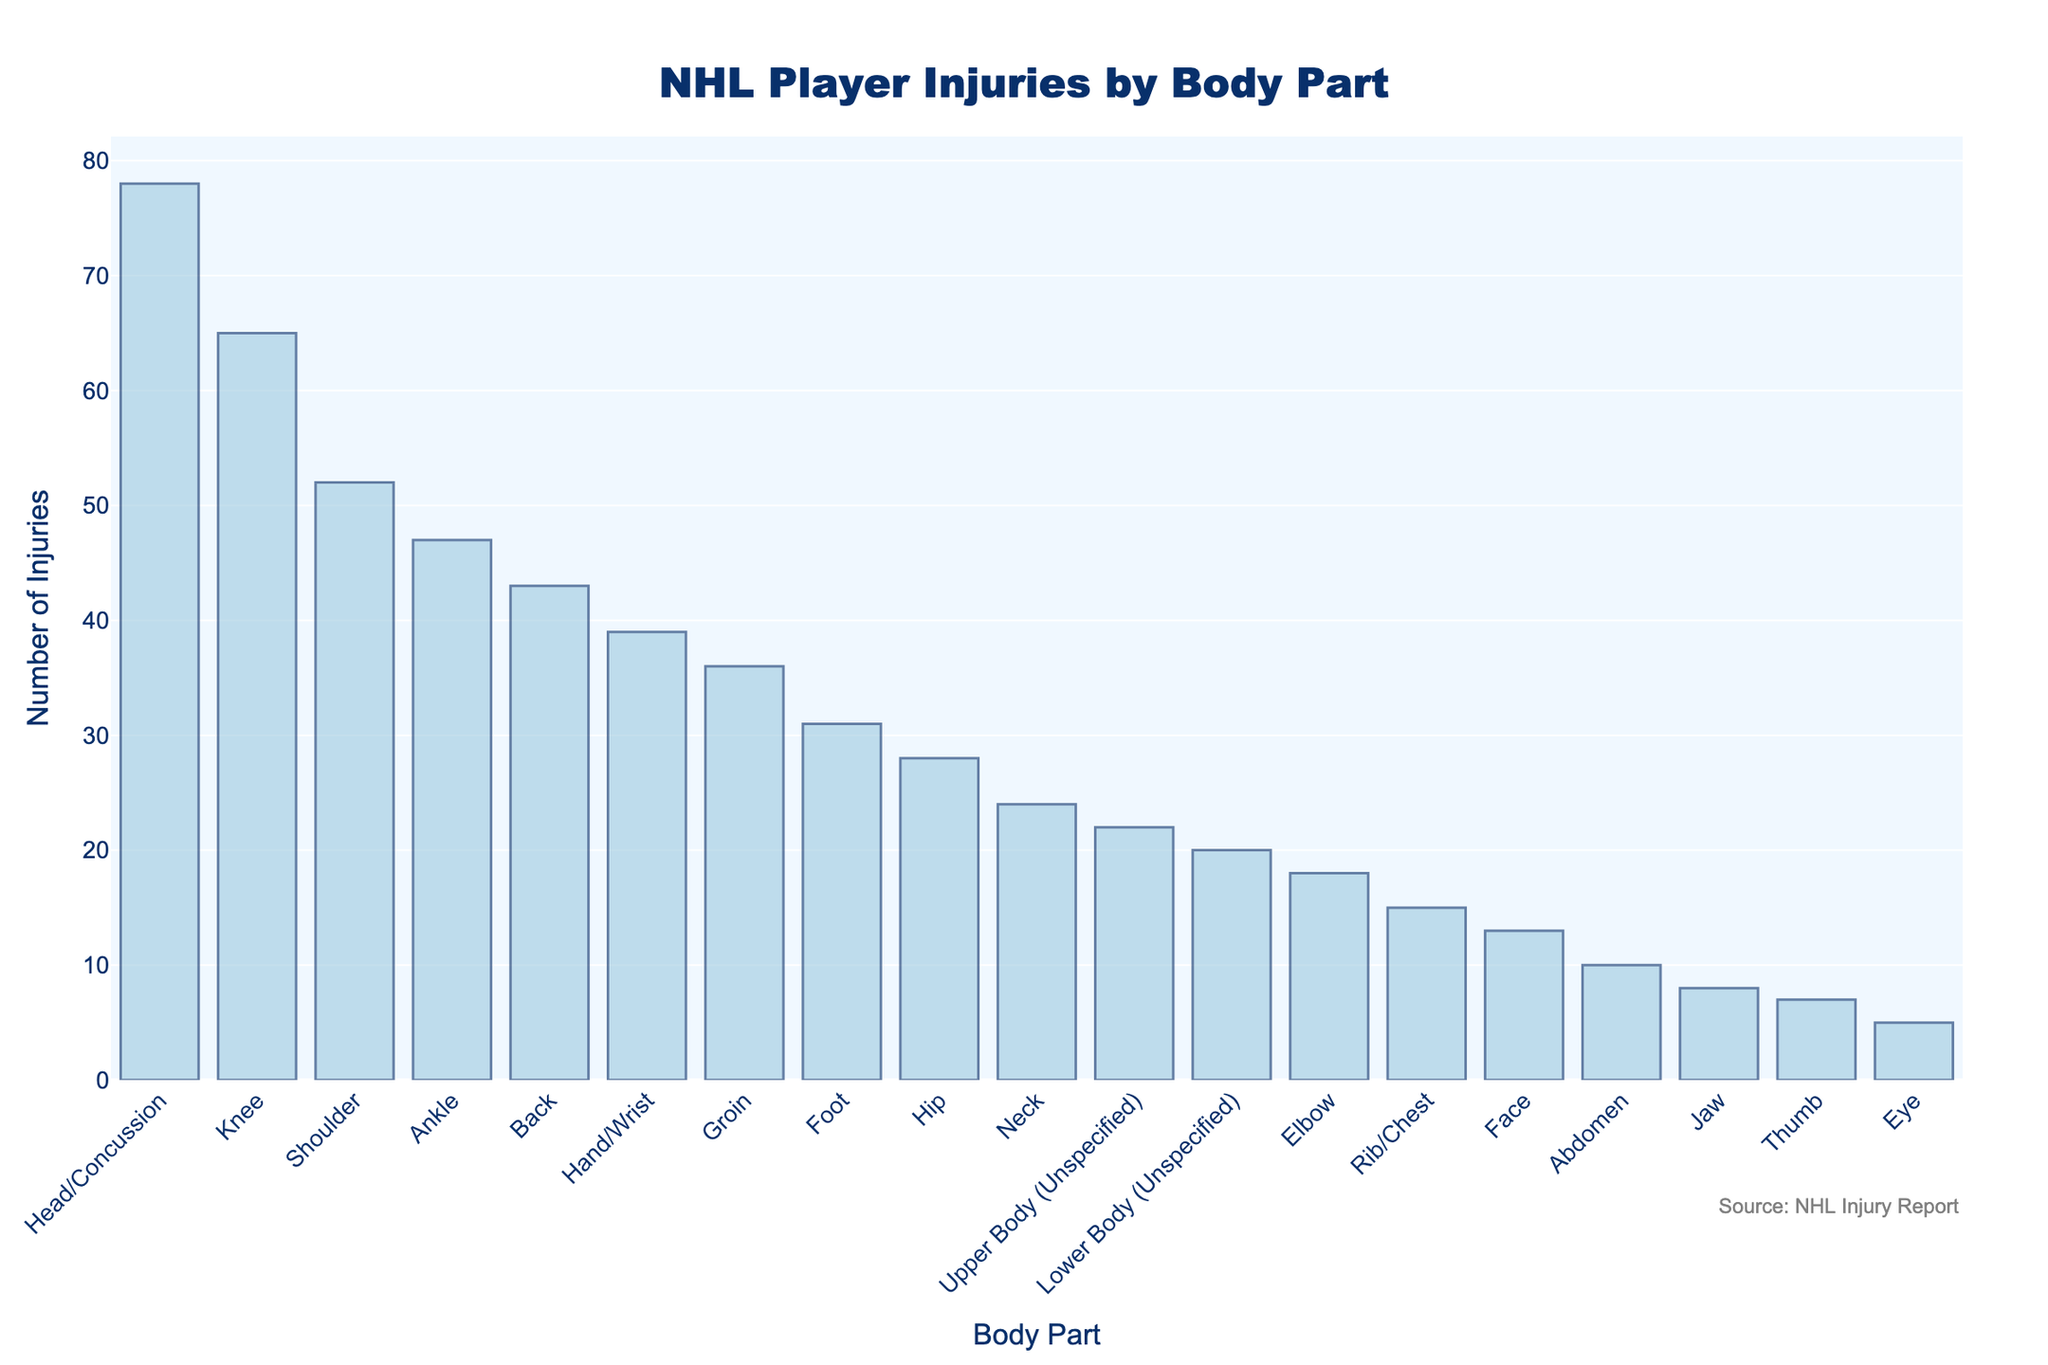What is the body part with the highest number of injuries? Observing the height of the bars, the tallest bar represents the "Head/Concussion" category with 78 injuries, making it the body part with the highest number of injuries.
Answer: Head/Concussion How many more injuries are there for the head compared to the knee? The number of head injuries is 78, while knee injuries are 65. Subtracting the knee injuries from head injuries gives 78 - 65 = 13.
Answer: 13 What is the sum of injuries for the shoulder, ankle, and back? Adding the number of injuries for the shoulder (52), ankle (47), and back (43) gives 52 + 47 + 43 = 142.
Answer: 142 Which has more injuries, the foot or the hip? By comparing the heights of the bars for "Foot" and "Hip", we see that the foot has 31 injuries and the hip has 28.
Answer: Foot What is the combined number of injuries for all unspecified body parts? Summing up injuries for "Upper Body (Unspecified)" and "Lower Body (Unspecified)", we get 22 + 20 = 42.
Answer: 42 Which body part has the least number of injuries, and how many? The shortest bar represents the "Eye" category with 5 injuries, making it the least injured body part.
Answer: Eye, 5 If the total number of injuries is apportioned equally among knee, shoulder, and ankle, what would be the average number of injuries for these body parts? The total number of injuries for knee (65), shoulder (52), and ankle (47) is 65 + 52 + 47 = 164. Dividing by the number of body parts (3) gives 164 / 3 ≈ 54.67.
Answer: 54.67 Are injuries to the elbow more or less frequent than injuries to the rib/chest? Comparing the heights of the bars, elbow injuries are 18 while rib/chest injuries are 15, indicating that elbow injuries are more frequent.
Answer: More Between "Head/Concussion" and "Upper Body (Unspecified)", which category has more than triple the number of injuries? Head/Concussion has 78 injuries and Upper Body (Unspecified) has 22 injuries. Checking if 78 is more than triple of 22: 22 * 3 = 66, and since 78 > 66, it's more than triple.
Answer: Head/Concussion 